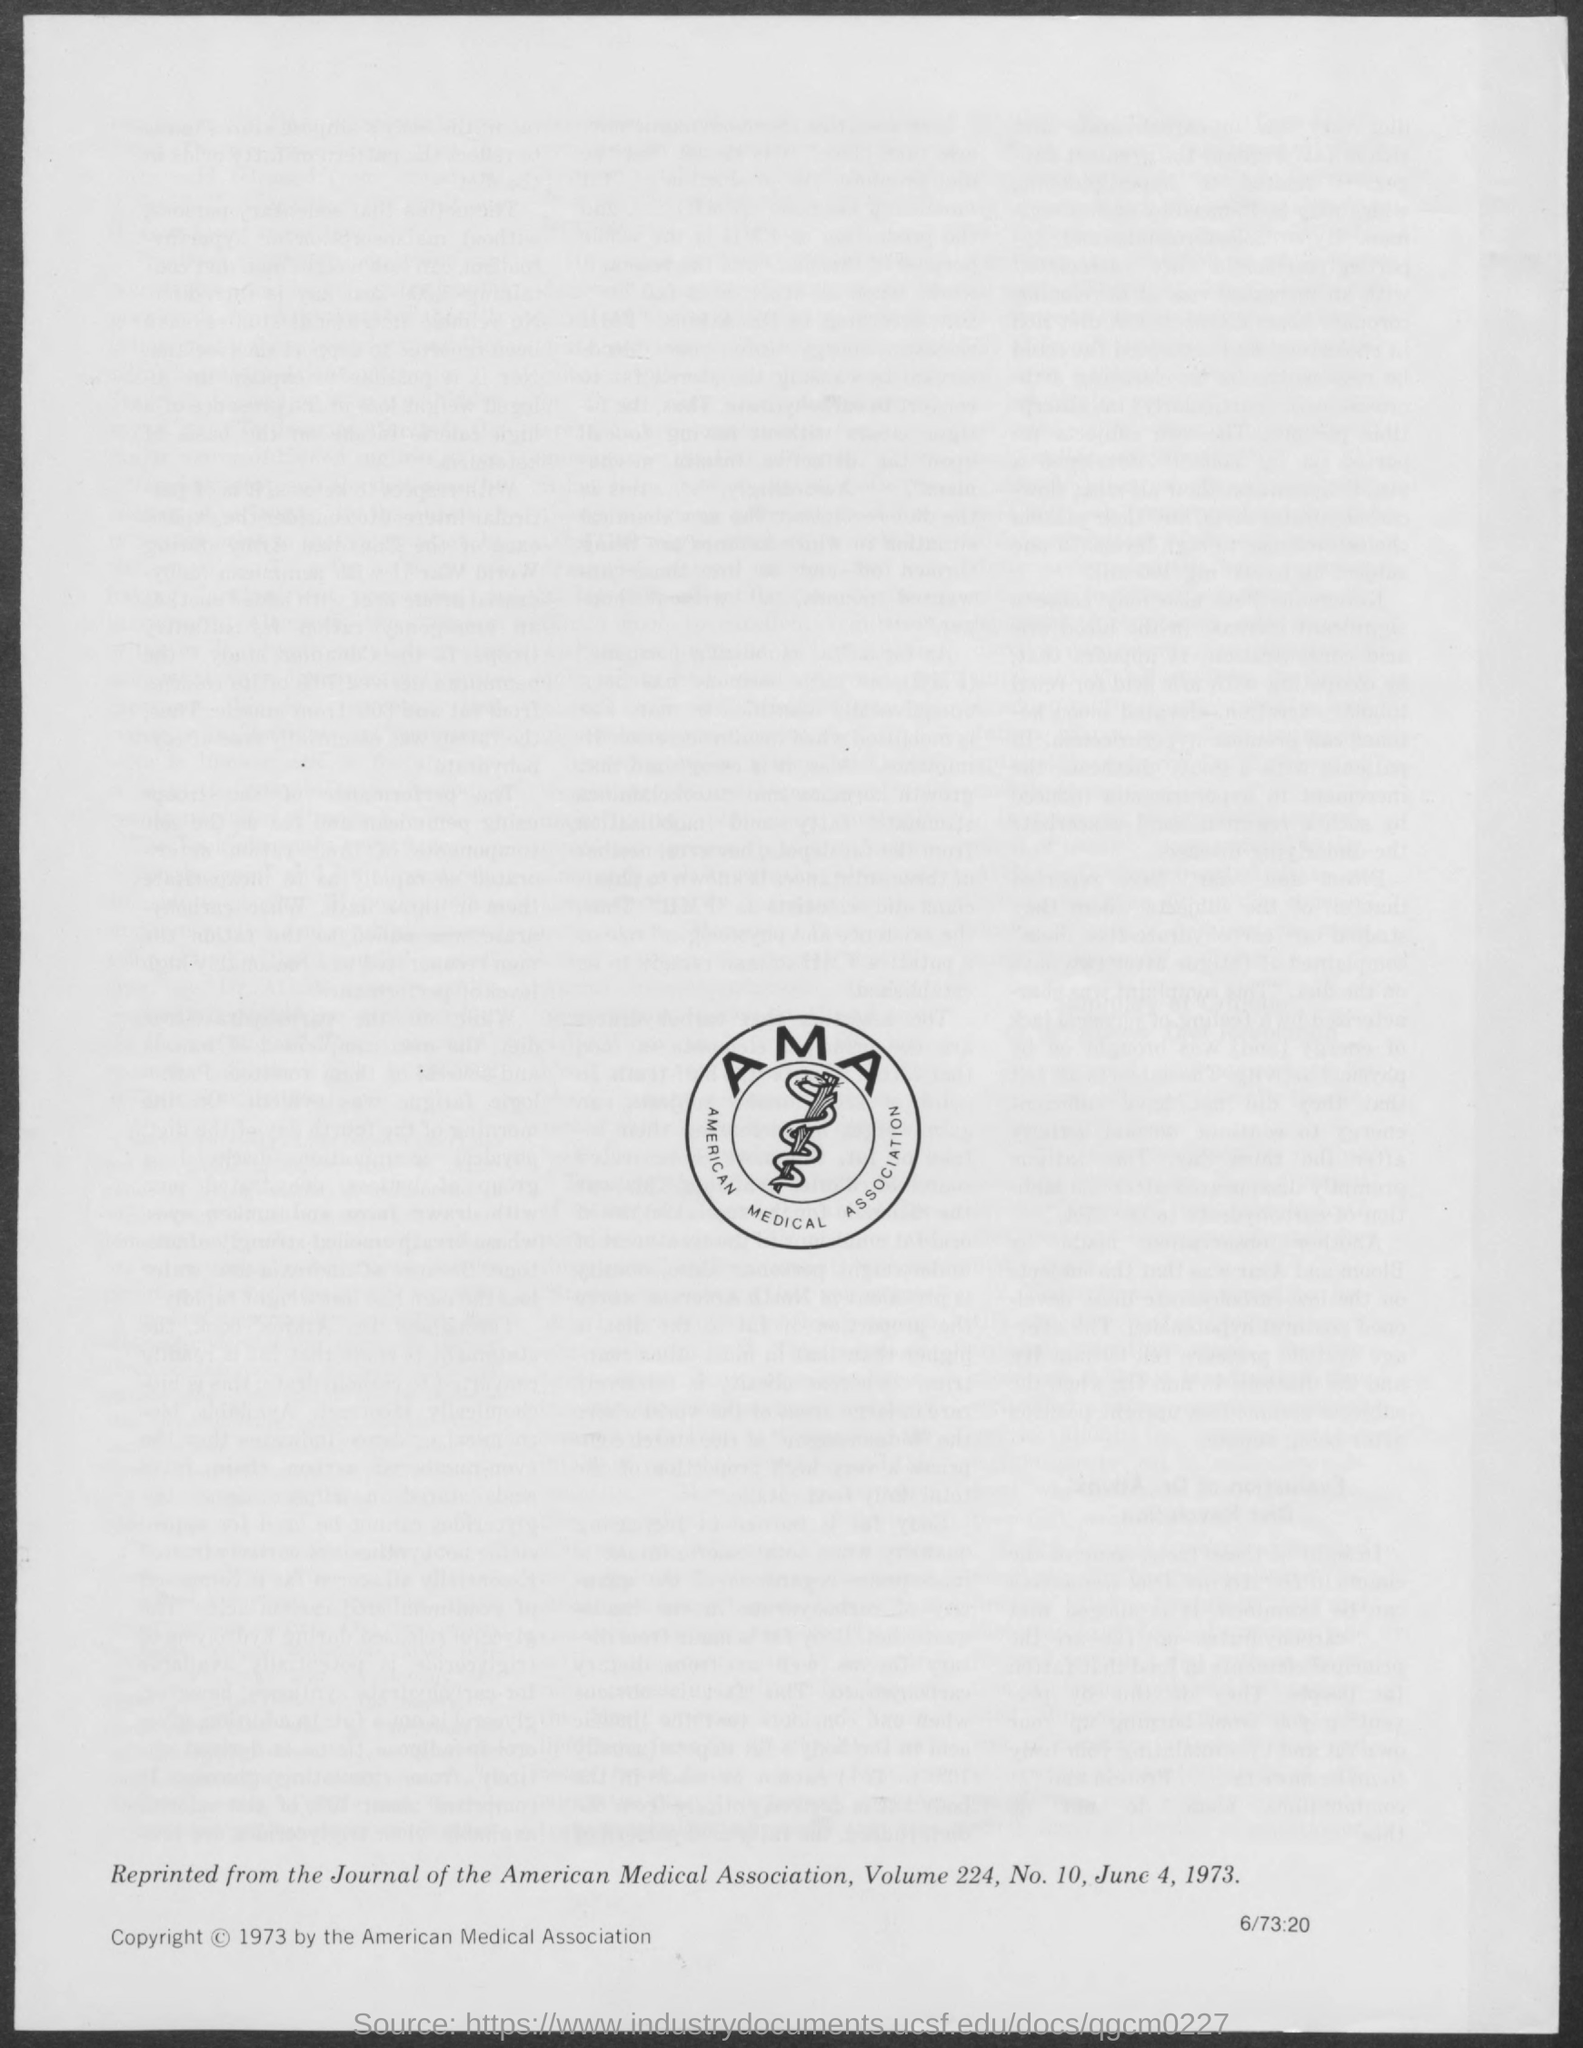What is the full form of AMA?
Provide a succinct answer. American Medical Association. What is the date mentioned in the document?
Your answer should be very brief. June 4, 1973. 